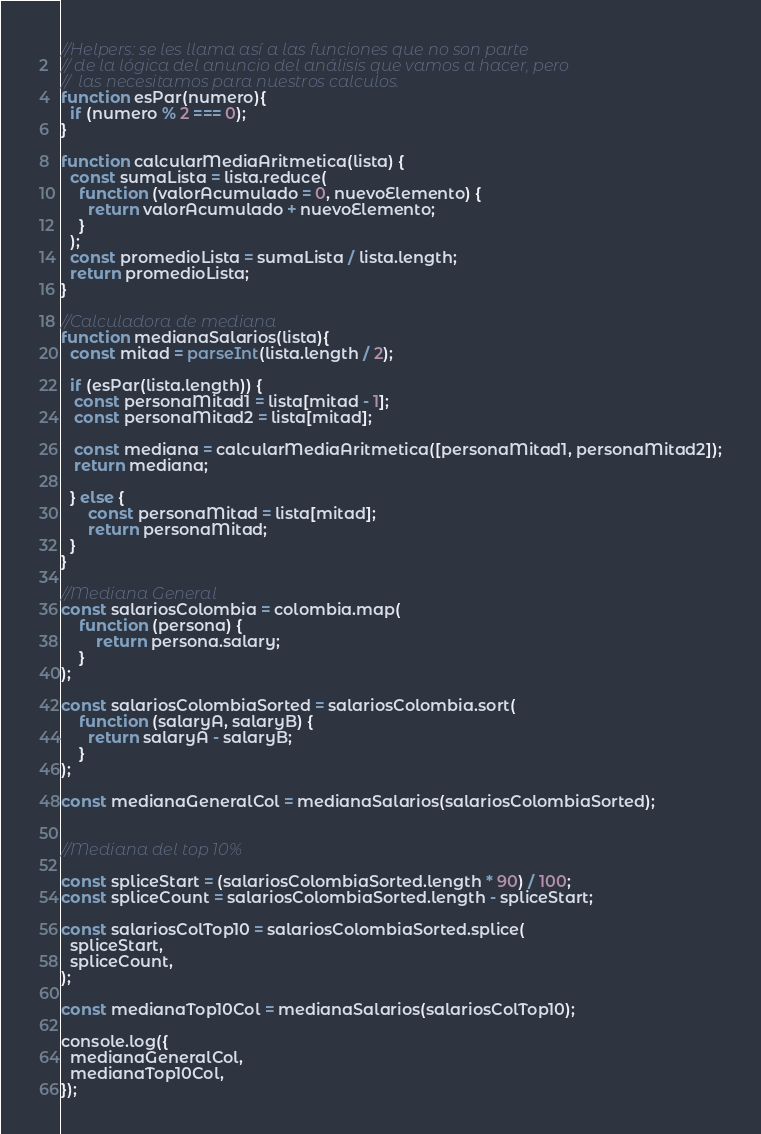<code> <loc_0><loc_0><loc_500><loc_500><_JavaScript_>//Helpers: se les llama así a las funciones que no son parte 
// de la lógica del anuncio del análisis que vamos a hacer, pero
//  las necesitamos para nuestros calculos.
function esPar(numero){
  if (numero % 2 === 0);
}

function calcularMediaAritmetica(lista) {
  const sumaLista = lista.reduce(
    function (valorAcumulado = 0, nuevoElemento) {
      return valorAcumulado + nuevoElemento;
    }
  );
  const promedioLista = sumaLista / lista.length;
  return promedioLista;
}

//Calculadora de mediana
function medianaSalarios(lista){
  const mitad = parseInt(lista.length / 2);

  if (esPar(lista.length)) {
   const personaMitad1 = lista[mitad - 1];
   const personaMitad2 = lista[mitad];

   const mediana = calcularMediaAritmetica([personaMitad1, personaMitad2]);
   return mediana;

  } else {
      const personaMitad = lista[mitad];
      return personaMitad;
  }
}

//Mediana General
const salariosColombia = colombia.map(
    function (persona) {
        return persona.salary;
    }
);

const salariosColombiaSorted = salariosColombia.sort(
    function (salaryA, salaryB) {
      return salaryA - salaryB;
    }
);

const medianaGeneralCol = medianaSalarios(salariosColombiaSorted);


//Mediana del top 10%

const spliceStart = (salariosColombiaSorted.length * 90) / 100;
const spliceCount = salariosColombiaSorted.length - spliceStart;

const salariosColTop10 = salariosColombiaSorted.splice(
  spliceStart,
  spliceCount,
);

const medianaTop10Col = medianaSalarios(salariosColTop10);

console.log({
  medianaGeneralCol,
  medianaTop10Col,
});</code> 